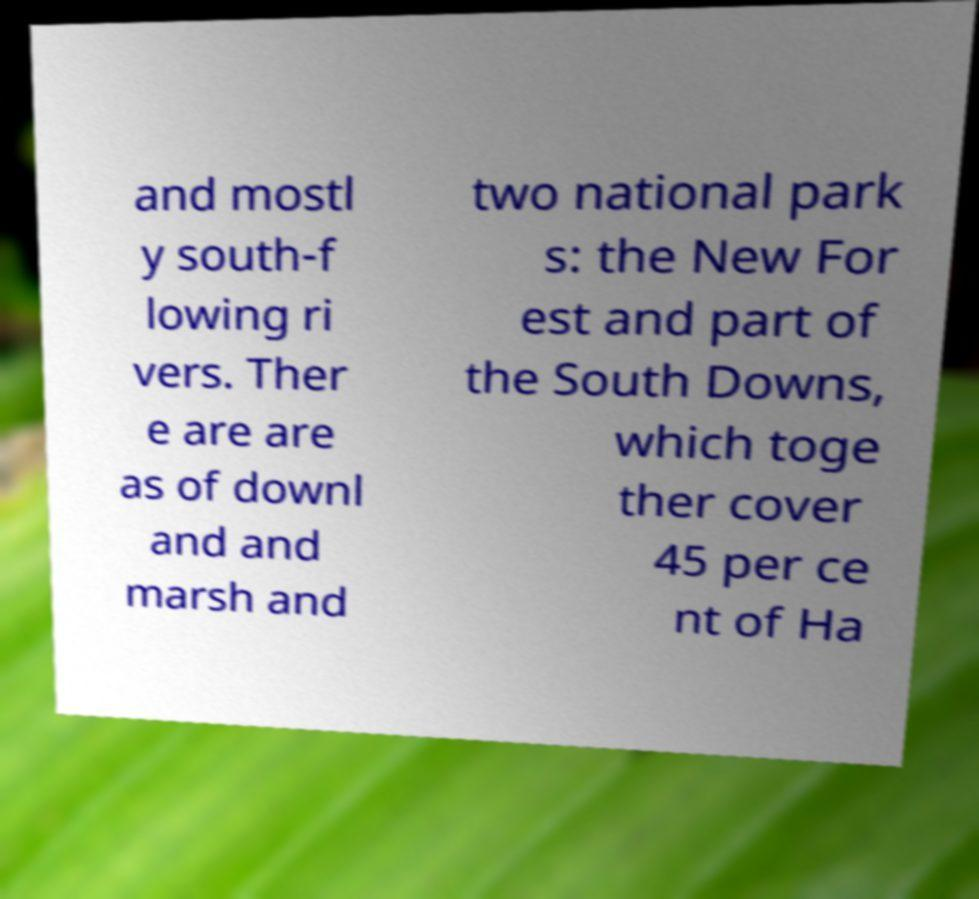Please read and relay the text visible in this image. What does it say? and mostl y south-f lowing ri vers. Ther e are are as of downl and and marsh and two national park s: the New For est and part of the South Downs, which toge ther cover 45 per ce nt of Ha 